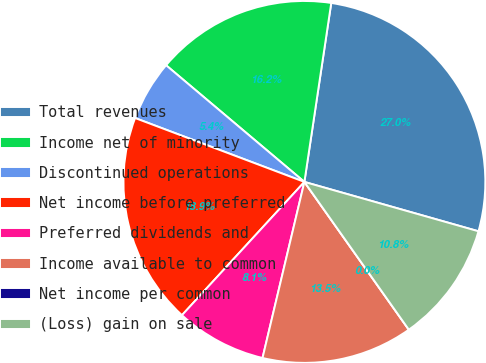<chart> <loc_0><loc_0><loc_500><loc_500><pie_chart><fcel>Total revenues<fcel>Income net of minority<fcel>Discontinued operations<fcel>Net income before preferred<fcel>Preferred dividends and<fcel>Income available to common<fcel>Net income per common<fcel>(Loss) gain on sale<nl><fcel>27.03%<fcel>16.22%<fcel>5.41%<fcel>18.92%<fcel>8.11%<fcel>13.51%<fcel>0.0%<fcel>10.81%<nl></chart> 